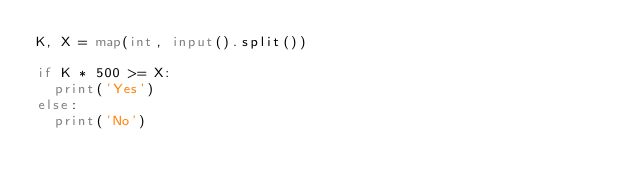<code> <loc_0><loc_0><loc_500><loc_500><_Python_>K, X = map(int, input().split())

if K * 500 >= X:
  print('Yes')
else:
  print('No')

</code> 